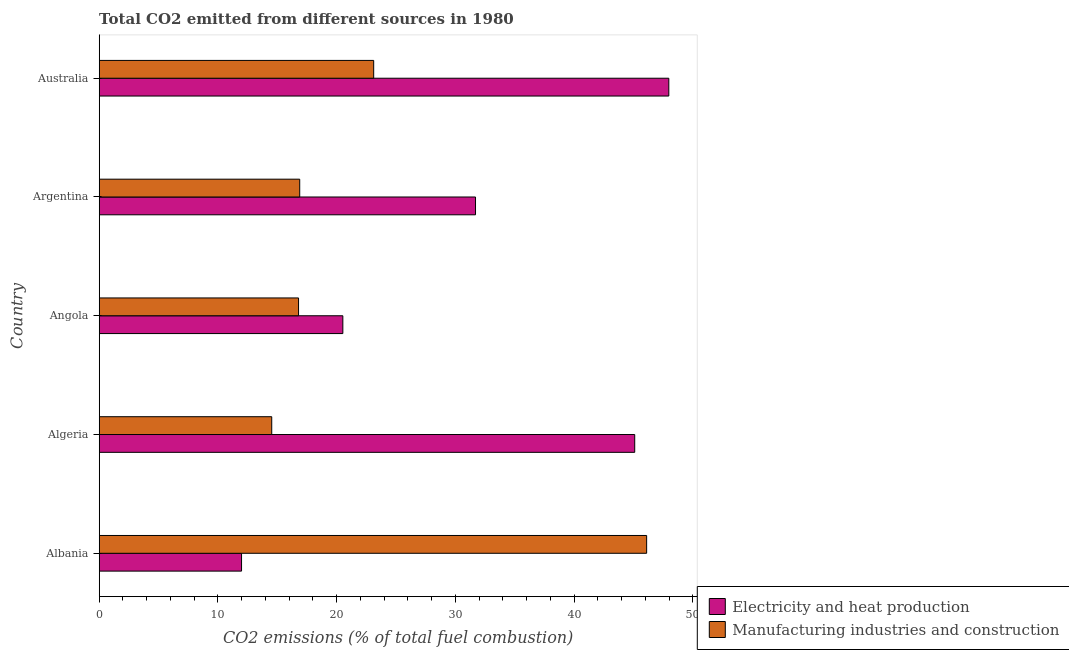Are the number of bars per tick equal to the number of legend labels?
Ensure brevity in your answer.  Yes. Are the number of bars on each tick of the Y-axis equal?
Keep it short and to the point. Yes. How many bars are there on the 3rd tick from the bottom?
Make the answer very short. 2. In how many cases, is the number of bars for a given country not equal to the number of legend labels?
Offer a very short reply. 0. What is the co2 emissions due to electricity and heat production in Angola?
Your answer should be very brief. 20.52. Across all countries, what is the maximum co2 emissions due to manufacturing industries?
Make the answer very short. 46.11. Across all countries, what is the minimum co2 emissions due to manufacturing industries?
Make the answer very short. 14.53. In which country was the co2 emissions due to manufacturing industries maximum?
Keep it short and to the point. Albania. In which country was the co2 emissions due to electricity and heat production minimum?
Your answer should be very brief. Albania. What is the total co2 emissions due to manufacturing industries in the graph?
Give a very brief answer. 117.45. What is the difference between the co2 emissions due to manufacturing industries in Albania and that in Algeria?
Make the answer very short. 31.58. What is the difference between the co2 emissions due to manufacturing industries in Angola and the co2 emissions due to electricity and heat production in Algeria?
Provide a succinct answer. -28.32. What is the average co2 emissions due to electricity and heat production per country?
Your answer should be very brief. 31.46. What is the difference between the co2 emissions due to manufacturing industries and co2 emissions due to electricity and heat production in Albania?
Provide a short and direct response. 34.12. In how many countries, is the co2 emissions due to electricity and heat production greater than 42 %?
Provide a short and direct response. 2. What is the ratio of the co2 emissions due to electricity and heat production in Angola to that in Argentina?
Keep it short and to the point. 0.65. Is the co2 emissions due to electricity and heat production in Angola less than that in Australia?
Your answer should be very brief. Yes. What is the difference between the highest and the second highest co2 emissions due to manufacturing industries?
Provide a succinct answer. 22.99. What is the difference between the highest and the lowest co2 emissions due to manufacturing industries?
Make the answer very short. 31.58. In how many countries, is the co2 emissions due to electricity and heat production greater than the average co2 emissions due to electricity and heat production taken over all countries?
Provide a short and direct response. 3. Is the sum of the co2 emissions due to electricity and heat production in Angola and Australia greater than the maximum co2 emissions due to manufacturing industries across all countries?
Your answer should be very brief. Yes. What does the 1st bar from the top in Algeria represents?
Ensure brevity in your answer.  Manufacturing industries and construction. What does the 2nd bar from the bottom in Australia represents?
Offer a terse response. Manufacturing industries and construction. How many bars are there?
Your response must be concise. 10. How many countries are there in the graph?
Your response must be concise. 5. What is the difference between two consecutive major ticks on the X-axis?
Give a very brief answer. 10. Does the graph contain any zero values?
Offer a terse response. No. Does the graph contain grids?
Give a very brief answer. No. How are the legend labels stacked?
Offer a very short reply. Vertical. What is the title of the graph?
Your answer should be compact. Total CO2 emitted from different sources in 1980. Does "Secondary school" appear as one of the legend labels in the graph?
Your answer should be very brief. No. What is the label or title of the X-axis?
Offer a terse response. CO2 emissions (% of total fuel combustion). What is the CO2 emissions (% of total fuel combustion) in Electricity and heat production in Albania?
Make the answer very short. 11.99. What is the CO2 emissions (% of total fuel combustion) in Manufacturing industries and construction in Albania?
Offer a terse response. 46.11. What is the CO2 emissions (% of total fuel combustion) of Electricity and heat production in Algeria?
Your answer should be very brief. 45.11. What is the CO2 emissions (% of total fuel combustion) in Manufacturing industries and construction in Algeria?
Your answer should be compact. 14.53. What is the CO2 emissions (% of total fuel combustion) in Electricity and heat production in Angola?
Your answer should be compact. 20.52. What is the CO2 emissions (% of total fuel combustion) in Manufacturing industries and construction in Angola?
Keep it short and to the point. 16.79. What is the CO2 emissions (% of total fuel combustion) of Electricity and heat production in Argentina?
Offer a terse response. 31.7. What is the CO2 emissions (% of total fuel combustion) of Manufacturing industries and construction in Argentina?
Offer a very short reply. 16.89. What is the CO2 emissions (% of total fuel combustion) of Electricity and heat production in Australia?
Keep it short and to the point. 47.98. What is the CO2 emissions (% of total fuel combustion) of Manufacturing industries and construction in Australia?
Offer a terse response. 23.12. Across all countries, what is the maximum CO2 emissions (% of total fuel combustion) of Electricity and heat production?
Provide a succinct answer. 47.98. Across all countries, what is the maximum CO2 emissions (% of total fuel combustion) in Manufacturing industries and construction?
Offer a very short reply. 46.11. Across all countries, what is the minimum CO2 emissions (% of total fuel combustion) in Electricity and heat production?
Provide a succinct answer. 11.99. Across all countries, what is the minimum CO2 emissions (% of total fuel combustion) in Manufacturing industries and construction?
Make the answer very short. 14.53. What is the total CO2 emissions (% of total fuel combustion) in Electricity and heat production in the graph?
Your answer should be very brief. 157.3. What is the total CO2 emissions (% of total fuel combustion) of Manufacturing industries and construction in the graph?
Give a very brief answer. 117.45. What is the difference between the CO2 emissions (% of total fuel combustion) of Electricity and heat production in Albania and that in Algeria?
Your response must be concise. -33.12. What is the difference between the CO2 emissions (% of total fuel combustion) in Manufacturing industries and construction in Albania and that in Algeria?
Offer a terse response. 31.58. What is the difference between the CO2 emissions (% of total fuel combustion) of Electricity and heat production in Albania and that in Angola?
Give a very brief answer. -8.53. What is the difference between the CO2 emissions (% of total fuel combustion) of Manufacturing industries and construction in Albania and that in Angola?
Your answer should be compact. 29.32. What is the difference between the CO2 emissions (% of total fuel combustion) of Electricity and heat production in Albania and that in Argentina?
Keep it short and to the point. -19.71. What is the difference between the CO2 emissions (% of total fuel combustion) of Manufacturing industries and construction in Albania and that in Argentina?
Offer a very short reply. 29.22. What is the difference between the CO2 emissions (% of total fuel combustion) in Electricity and heat production in Albania and that in Australia?
Provide a short and direct response. -35.99. What is the difference between the CO2 emissions (% of total fuel combustion) of Manufacturing industries and construction in Albania and that in Australia?
Provide a short and direct response. 22.99. What is the difference between the CO2 emissions (% of total fuel combustion) in Electricity and heat production in Algeria and that in Angola?
Offer a very short reply. 24.59. What is the difference between the CO2 emissions (% of total fuel combustion) of Manufacturing industries and construction in Algeria and that in Angola?
Keep it short and to the point. -2.26. What is the difference between the CO2 emissions (% of total fuel combustion) of Electricity and heat production in Algeria and that in Argentina?
Your response must be concise. 13.41. What is the difference between the CO2 emissions (% of total fuel combustion) in Manufacturing industries and construction in Algeria and that in Argentina?
Your answer should be compact. -2.36. What is the difference between the CO2 emissions (% of total fuel combustion) in Electricity and heat production in Algeria and that in Australia?
Give a very brief answer. -2.87. What is the difference between the CO2 emissions (% of total fuel combustion) of Manufacturing industries and construction in Algeria and that in Australia?
Give a very brief answer. -8.59. What is the difference between the CO2 emissions (% of total fuel combustion) in Electricity and heat production in Angola and that in Argentina?
Provide a succinct answer. -11.18. What is the difference between the CO2 emissions (% of total fuel combustion) of Manufacturing industries and construction in Angola and that in Argentina?
Give a very brief answer. -0.1. What is the difference between the CO2 emissions (% of total fuel combustion) in Electricity and heat production in Angola and that in Australia?
Keep it short and to the point. -27.46. What is the difference between the CO2 emissions (% of total fuel combustion) in Manufacturing industries and construction in Angola and that in Australia?
Keep it short and to the point. -6.33. What is the difference between the CO2 emissions (% of total fuel combustion) of Electricity and heat production in Argentina and that in Australia?
Make the answer very short. -16.28. What is the difference between the CO2 emissions (% of total fuel combustion) in Manufacturing industries and construction in Argentina and that in Australia?
Offer a very short reply. -6.23. What is the difference between the CO2 emissions (% of total fuel combustion) of Electricity and heat production in Albania and the CO2 emissions (% of total fuel combustion) of Manufacturing industries and construction in Algeria?
Keep it short and to the point. -2.54. What is the difference between the CO2 emissions (% of total fuel combustion) of Electricity and heat production in Albania and the CO2 emissions (% of total fuel combustion) of Manufacturing industries and construction in Angola?
Your answer should be very brief. -4.8. What is the difference between the CO2 emissions (% of total fuel combustion) in Electricity and heat production in Albania and the CO2 emissions (% of total fuel combustion) in Manufacturing industries and construction in Argentina?
Your response must be concise. -4.9. What is the difference between the CO2 emissions (% of total fuel combustion) in Electricity and heat production in Albania and the CO2 emissions (% of total fuel combustion) in Manufacturing industries and construction in Australia?
Your answer should be compact. -11.13. What is the difference between the CO2 emissions (% of total fuel combustion) of Electricity and heat production in Algeria and the CO2 emissions (% of total fuel combustion) of Manufacturing industries and construction in Angola?
Offer a terse response. 28.32. What is the difference between the CO2 emissions (% of total fuel combustion) of Electricity and heat production in Algeria and the CO2 emissions (% of total fuel combustion) of Manufacturing industries and construction in Argentina?
Give a very brief answer. 28.22. What is the difference between the CO2 emissions (% of total fuel combustion) of Electricity and heat production in Algeria and the CO2 emissions (% of total fuel combustion) of Manufacturing industries and construction in Australia?
Make the answer very short. 21.99. What is the difference between the CO2 emissions (% of total fuel combustion) in Electricity and heat production in Angola and the CO2 emissions (% of total fuel combustion) in Manufacturing industries and construction in Argentina?
Give a very brief answer. 3.63. What is the difference between the CO2 emissions (% of total fuel combustion) of Electricity and heat production in Angola and the CO2 emissions (% of total fuel combustion) of Manufacturing industries and construction in Australia?
Your answer should be compact. -2.6. What is the difference between the CO2 emissions (% of total fuel combustion) in Electricity and heat production in Argentina and the CO2 emissions (% of total fuel combustion) in Manufacturing industries and construction in Australia?
Offer a terse response. 8.58. What is the average CO2 emissions (% of total fuel combustion) in Electricity and heat production per country?
Give a very brief answer. 31.46. What is the average CO2 emissions (% of total fuel combustion) of Manufacturing industries and construction per country?
Give a very brief answer. 23.49. What is the difference between the CO2 emissions (% of total fuel combustion) in Electricity and heat production and CO2 emissions (% of total fuel combustion) in Manufacturing industries and construction in Albania?
Offer a terse response. -34.12. What is the difference between the CO2 emissions (% of total fuel combustion) in Electricity and heat production and CO2 emissions (% of total fuel combustion) in Manufacturing industries and construction in Algeria?
Your response must be concise. 30.58. What is the difference between the CO2 emissions (% of total fuel combustion) in Electricity and heat production and CO2 emissions (% of total fuel combustion) in Manufacturing industries and construction in Angola?
Your answer should be compact. 3.73. What is the difference between the CO2 emissions (% of total fuel combustion) of Electricity and heat production and CO2 emissions (% of total fuel combustion) of Manufacturing industries and construction in Argentina?
Give a very brief answer. 14.81. What is the difference between the CO2 emissions (% of total fuel combustion) in Electricity and heat production and CO2 emissions (% of total fuel combustion) in Manufacturing industries and construction in Australia?
Offer a very short reply. 24.86. What is the ratio of the CO2 emissions (% of total fuel combustion) of Electricity and heat production in Albania to that in Algeria?
Offer a terse response. 0.27. What is the ratio of the CO2 emissions (% of total fuel combustion) in Manufacturing industries and construction in Albania to that in Algeria?
Offer a terse response. 3.17. What is the ratio of the CO2 emissions (% of total fuel combustion) in Electricity and heat production in Albania to that in Angola?
Keep it short and to the point. 0.58. What is the ratio of the CO2 emissions (% of total fuel combustion) of Manufacturing industries and construction in Albania to that in Angola?
Your response must be concise. 2.75. What is the ratio of the CO2 emissions (% of total fuel combustion) of Electricity and heat production in Albania to that in Argentina?
Your answer should be very brief. 0.38. What is the ratio of the CO2 emissions (% of total fuel combustion) of Manufacturing industries and construction in Albania to that in Argentina?
Make the answer very short. 2.73. What is the ratio of the CO2 emissions (% of total fuel combustion) of Electricity and heat production in Albania to that in Australia?
Provide a succinct answer. 0.25. What is the ratio of the CO2 emissions (% of total fuel combustion) of Manufacturing industries and construction in Albania to that in Australia?
Keep it short and to the point. 1.99. What is the ratio of the CO2 emissions (% of total fuel combustion) in Electricity and heat production in Algeria to that in Angola?
Your answer should be compact. 2.2. What is the ratio of the CO2 emissions (% of total fuel combustion) in Manufacturing industries and construction in Algeria to that in Angola?
Your response must be concise. 0.87. What is the ratio of the CO2 emissions (% of total fuel combustion) in Electricity and heat production in Algeria to that in Argentina?
Provide a short and direct response. 1.42. What is the ratio of the CO2 emissions (% of total fuel combustion) in Manufacturing industries and construction in Algeria to that in Argentina?
Ensure brevity in your answer.  0.86. What is the ratio of the CO2 emissions (% of total fuel combustion) of Electricity and heat production in Algeria to that in Australia?
Give a very brief answer. 0.94. What is the ratio of the CO2 emissions (% of total fuel combustion) in Manufacturing industries and construction in Algeria to that in Australia?
Your response must be concise. 0.63. What is the ratio of the CO2 emissions (% of total fuel combustion) of Electricity and heat production in Angola to that in Argentina?
Your answer should be compact. 0.65. What is the ratio of the CO2 emissions (% of total fuel combustion) of Manufacturing industries and construction in Angola to that in Argentina?
Offer a very short reply. 0.99. What is the ratio of the CO2 emissions (% of total fuel combustion) of Electricity and heat production in Angola to that in Australia?
Your answer should be very brief. 0.43. What is the ratio of the CO2 emissions (% of total fuel combustion) in Manufacturing industries and construction in Angola to that in Australia?
Give a very brief answer. 0.73. What is the ratio of the CO2 emissions (% of total fuel combustion) of Electricity and heat production in Argentina to that in Australia?
Your answer should be very brief. 0.66. What is the ratio of the CO2 emissions (% of total fuel combustion) of Manufacturing industries and construction in Argentina to that in Australia?
Your answer should be very brief. 0.73. What is the difference between the highest and the second highest CO2 emissions (% of total fuel combustion) of Electricity and heat production?
Provide a succinct answer. 2.87. What is the difference between the highest and the second highest CO2 emissions (% of total fuel combustion) in Manufacturing industries and construction?
Give a very brief answer. 22.99. What is the difference between the highest and the lowest CO2 emissions (% of total fuel combustion) in Electricity and heat production?
Provide a succinct answer. 35.99. What is the difference between the highest and the lowest CO2 emissions (% of total fuel combustion) of Manufacturing industries and construction?
Offer a very short reply. 31.58. 